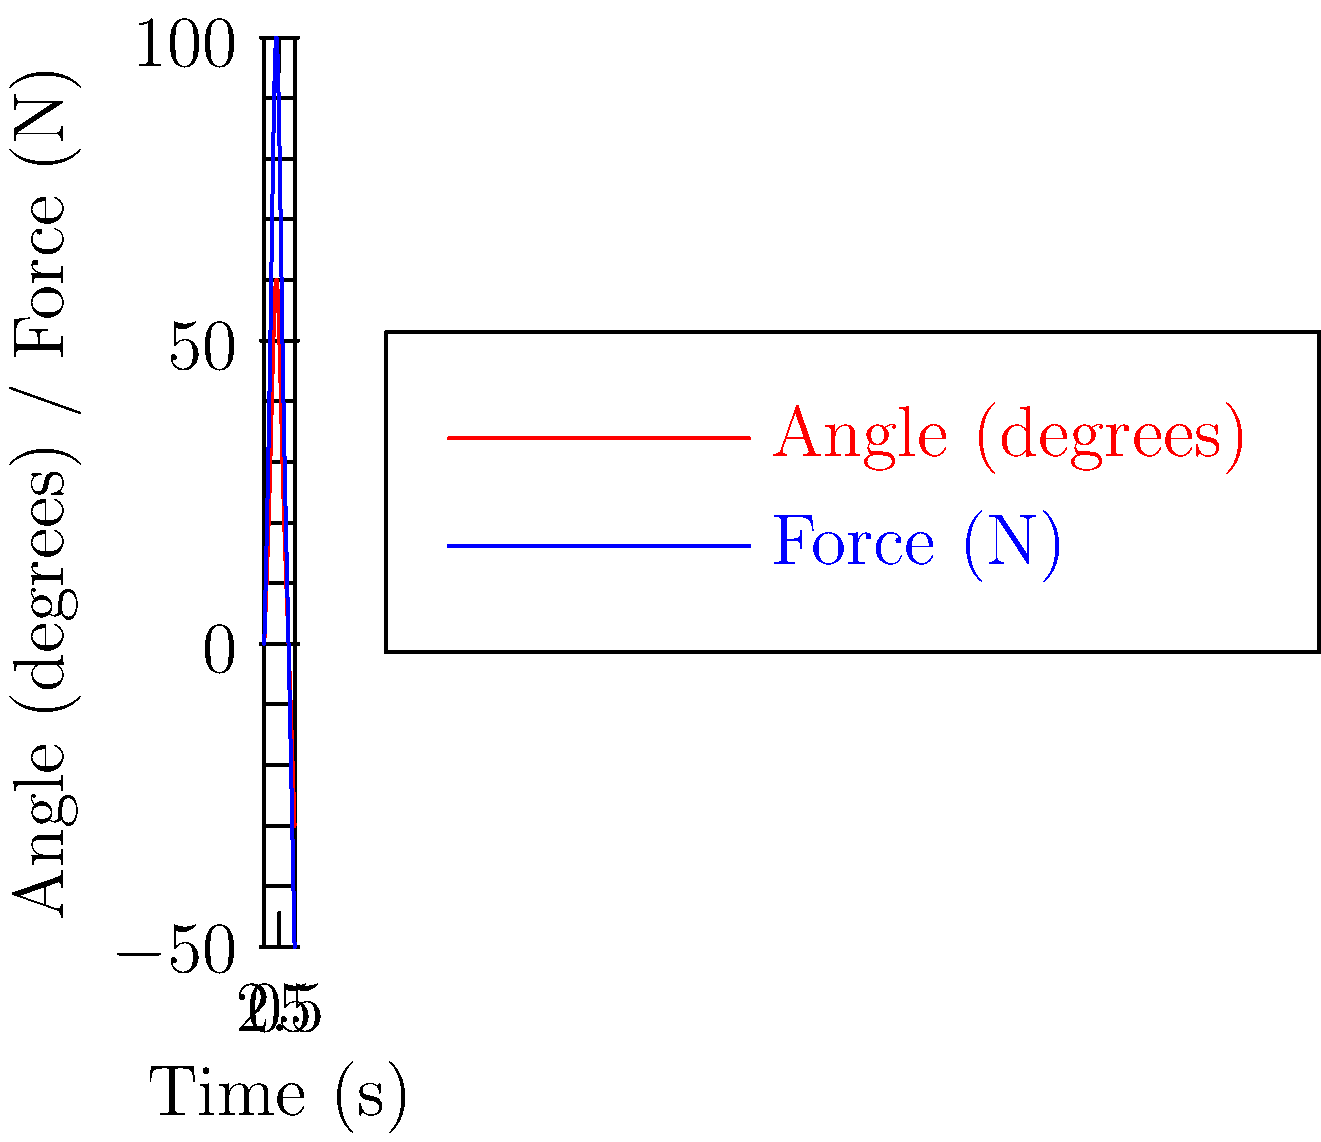Based on the biomechanical analysis of flag waving shown in the graph, what is the optimal angle and force combination for maximum visibility and impact during a party demonstration? To determine the optimal angle and force combination for maximum visibility and impact during flag waving, we need to analyze the graph:

1. The red line represents the angle of the flag, while the blue line represents the applied force.

2. We can see that both angle and force follow a similar pattern, peaking at the 2-second mark.

3. At the peak (2-second mark):
   - The angle reaches 60 degrees
   - The force reaches 100 N

4. This combination of maximum angle and force likely creates the most prominent visual display and generates the most attention.

5. The symmetrical nature of the graph suggests a rhythmic back-and-forth motion, which is effective for sustained demonstrations.

6. The negative values at the end of the cycle indicate the backward motion, completing the wave.

7. The gradual increase and decrease in both angle and force suggest a smooth, controlled motion that reduces fatigue and allows for extended periods of flag waving.

Therefore, the optimal combination for maximum visibility and impact is an angle of 60 degrees with an applied force of 100 N, achieved through a smooth, rhythmic motion.
Answer: 60 degrees at 100 N 